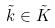<formula> <loc_0><loc_0><loc_500><loc_500>\tilde { k } \in \tilde { K }</formula> 